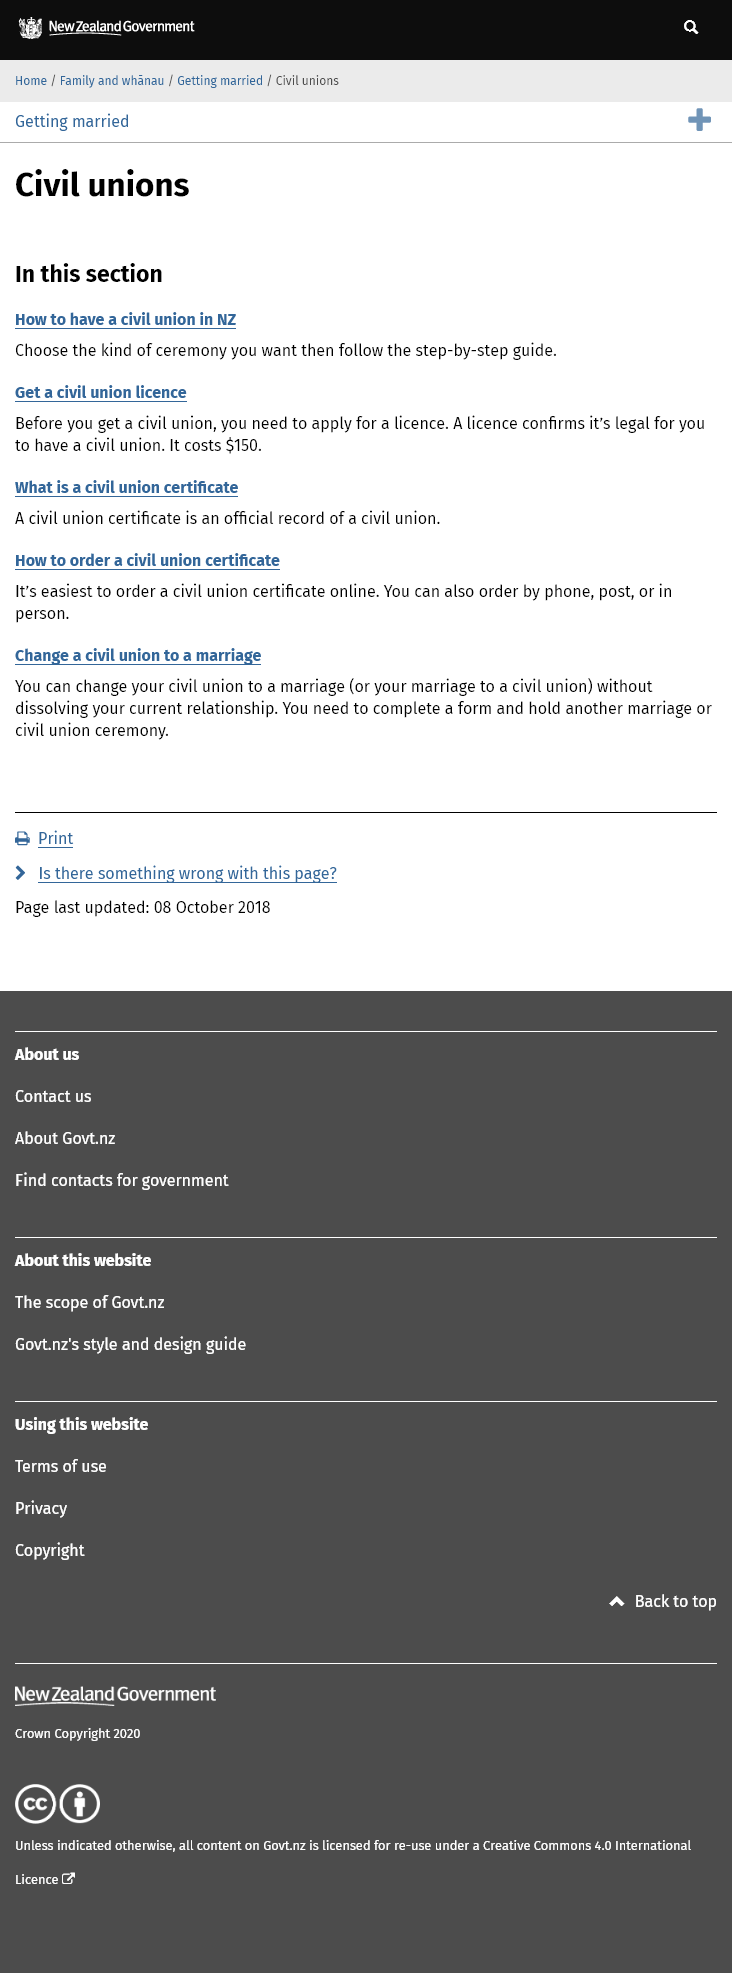Outline some significant characteristics in this image. A civil union certificate is a document that is issued by the government to officially recognize a civil union between two individuals. Yes, it is possible to order a civil union certificate over the phone. A civil union license costs $150. 